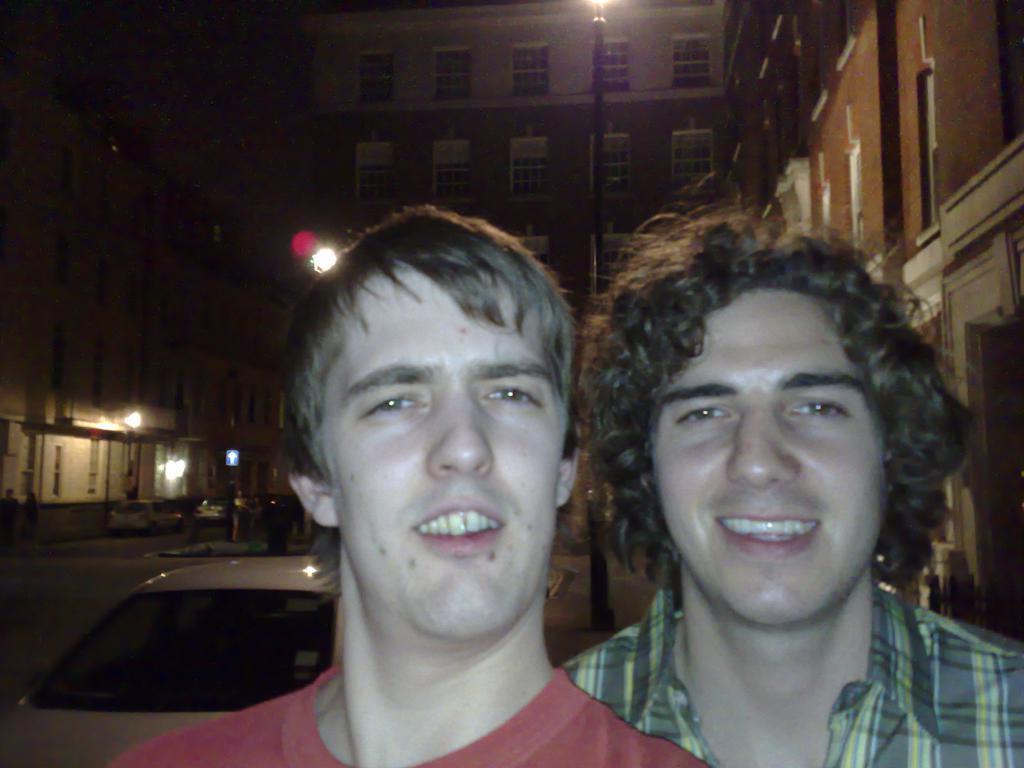Can you describe this image briefly? As we can see in the image in the front there are two people. The man on the right side is wearing green color shirt and the man on the left side is wearing red color t shirt. In the background there are buildings and lights. Here there is a car. 